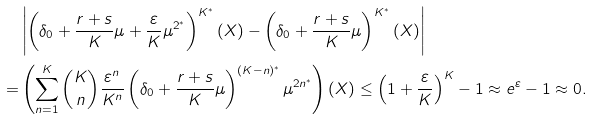Convert formula to latex. <formula><loc_0><loc_0><loc_500><loc_500>& \left | \left ( \delta _ { 0 } + \frac { r + s } { K } \mu + \frac { \varepsilon } { K } \mu ^ { 2 ^ { * } } \right ) ^ { K ^ { * } } \left ( X \right ) - \left ( \delta _ { 0 } + \frac { r + s } { K } \mu \right ) ^ { K ^ { * } } \left ( X \right ) \right | \\ = & \left ( \sum _ { n = 1 } ^ { K } { K \choose n } \frac { \varepsilon ^ { n } } { K ^ { n } } \left ( \delta _ { 0 } + \frac { r + s } { K } \mu \right ) ^ { ( K - n ) ^ { * } } \mu ^ { 2 n ^ { * } } \right ) \left ( X \right ) \leq \left ( 1 + \frac { \varepsilon } { K } \right ) ^ { K } - 1 \approx e ^ { \varepsilon } - 1 \approx 0 .</formula> 